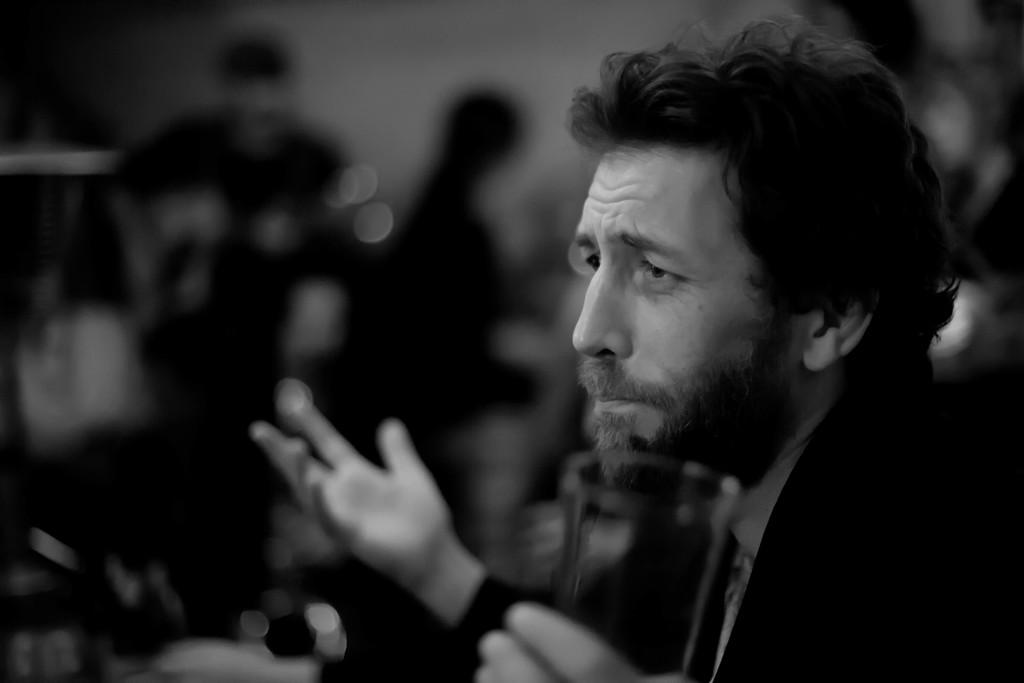What is the color scheme of the image? The image is black and white. Can you describe the person in the image? There is a person in the image. What is the person holding in the image? The person is holding a glass. What type of sack is the person carrying in the image? There is no sack present in the image; the person is holding a glass. Is the person in the image a doctor? The image does not provide any information about the person's profession, so it cannot be determined if they are a doctor. 